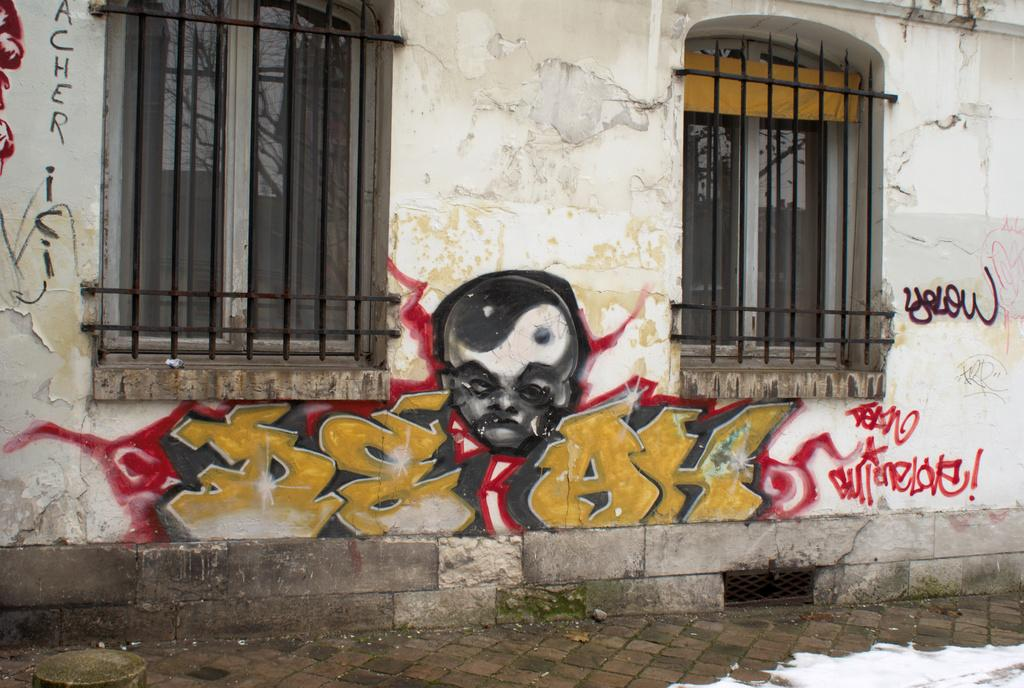What type of structure is present in the image? There is a building in the image. What architectural feature can be seen on the building? The building has windows. What type of artwork is present on the building? There is graffiti on the wall of the building. How many bears are climbing the building in the image? There are no bears present in the image. What type of hook can be seen attached to the building in the image? There is no hook present in the image. 